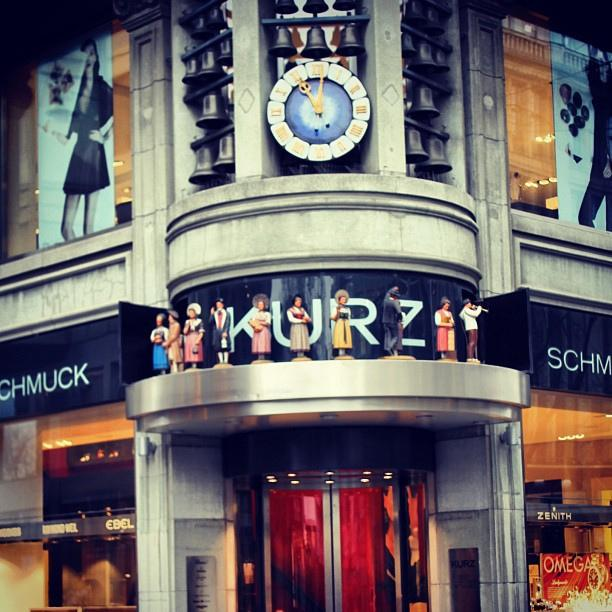What sort of wearable item is available for sale within?

Choices:
A) watch
B) neck gear
C) scarf
D) socks watch 